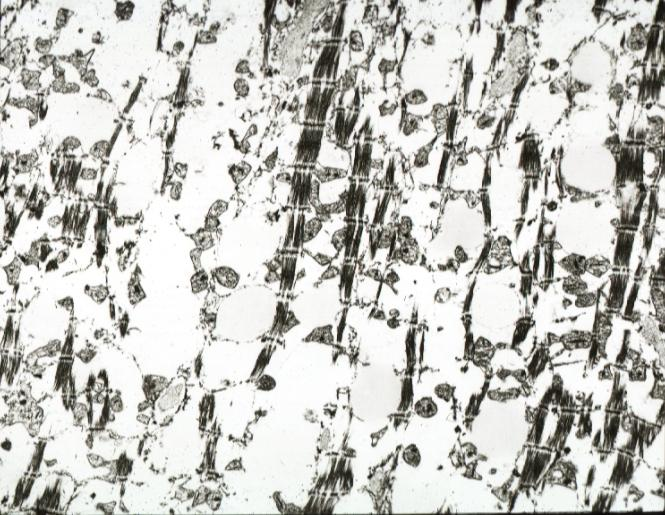what does show lesion containing no lipid?
Answer the question using a single word or phrase. Myocytolysis not 